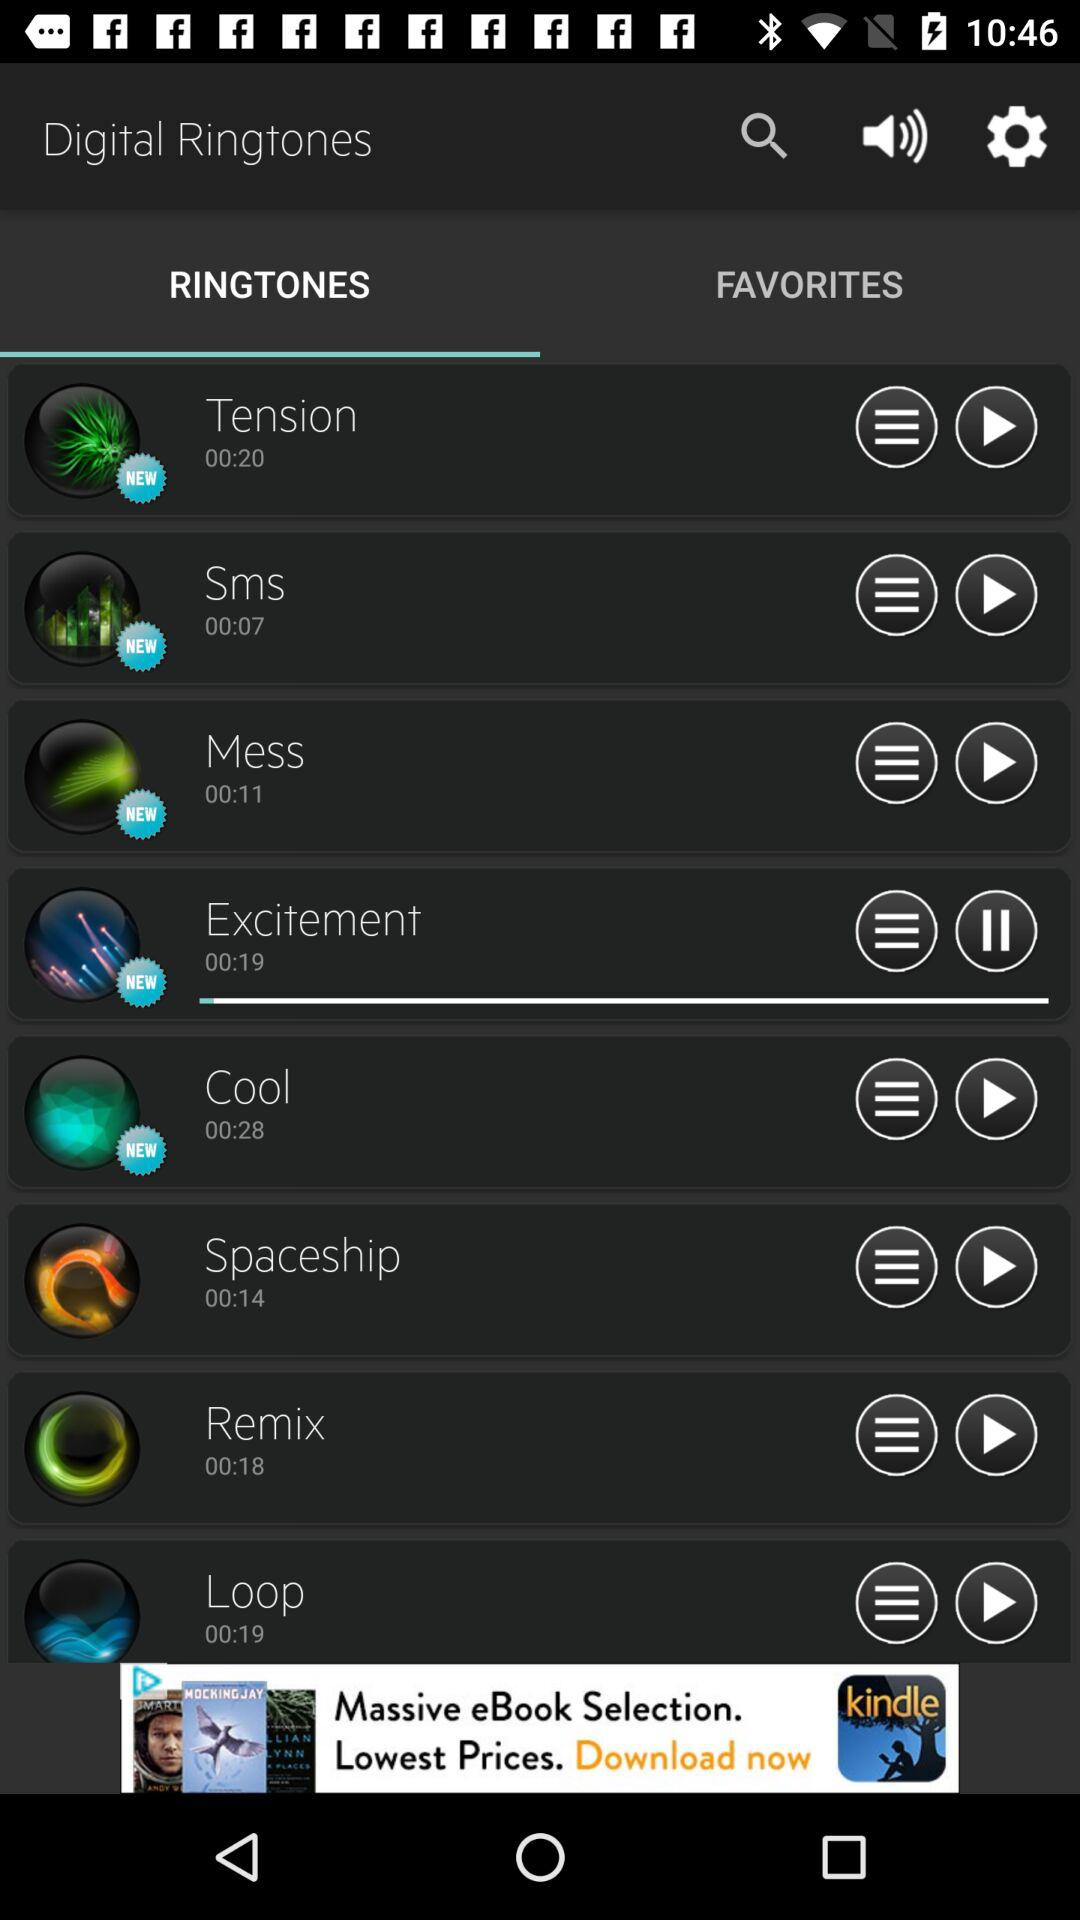What is the audio duration of "Tension"? The audio duration of "Tension" is 20 seconds. 